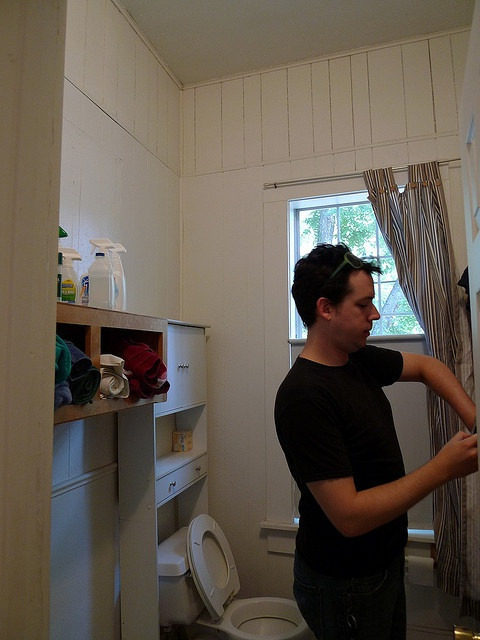Describe the objects in this image and their specific colors. I can see people in gray, black, and maroon tones, toilet in gray and black tones, bottle in gray and darkgray tones, bottle in gray, darkgray, and olive tones, and bottle in gray, darkgray, and lightblue tones in this image. 